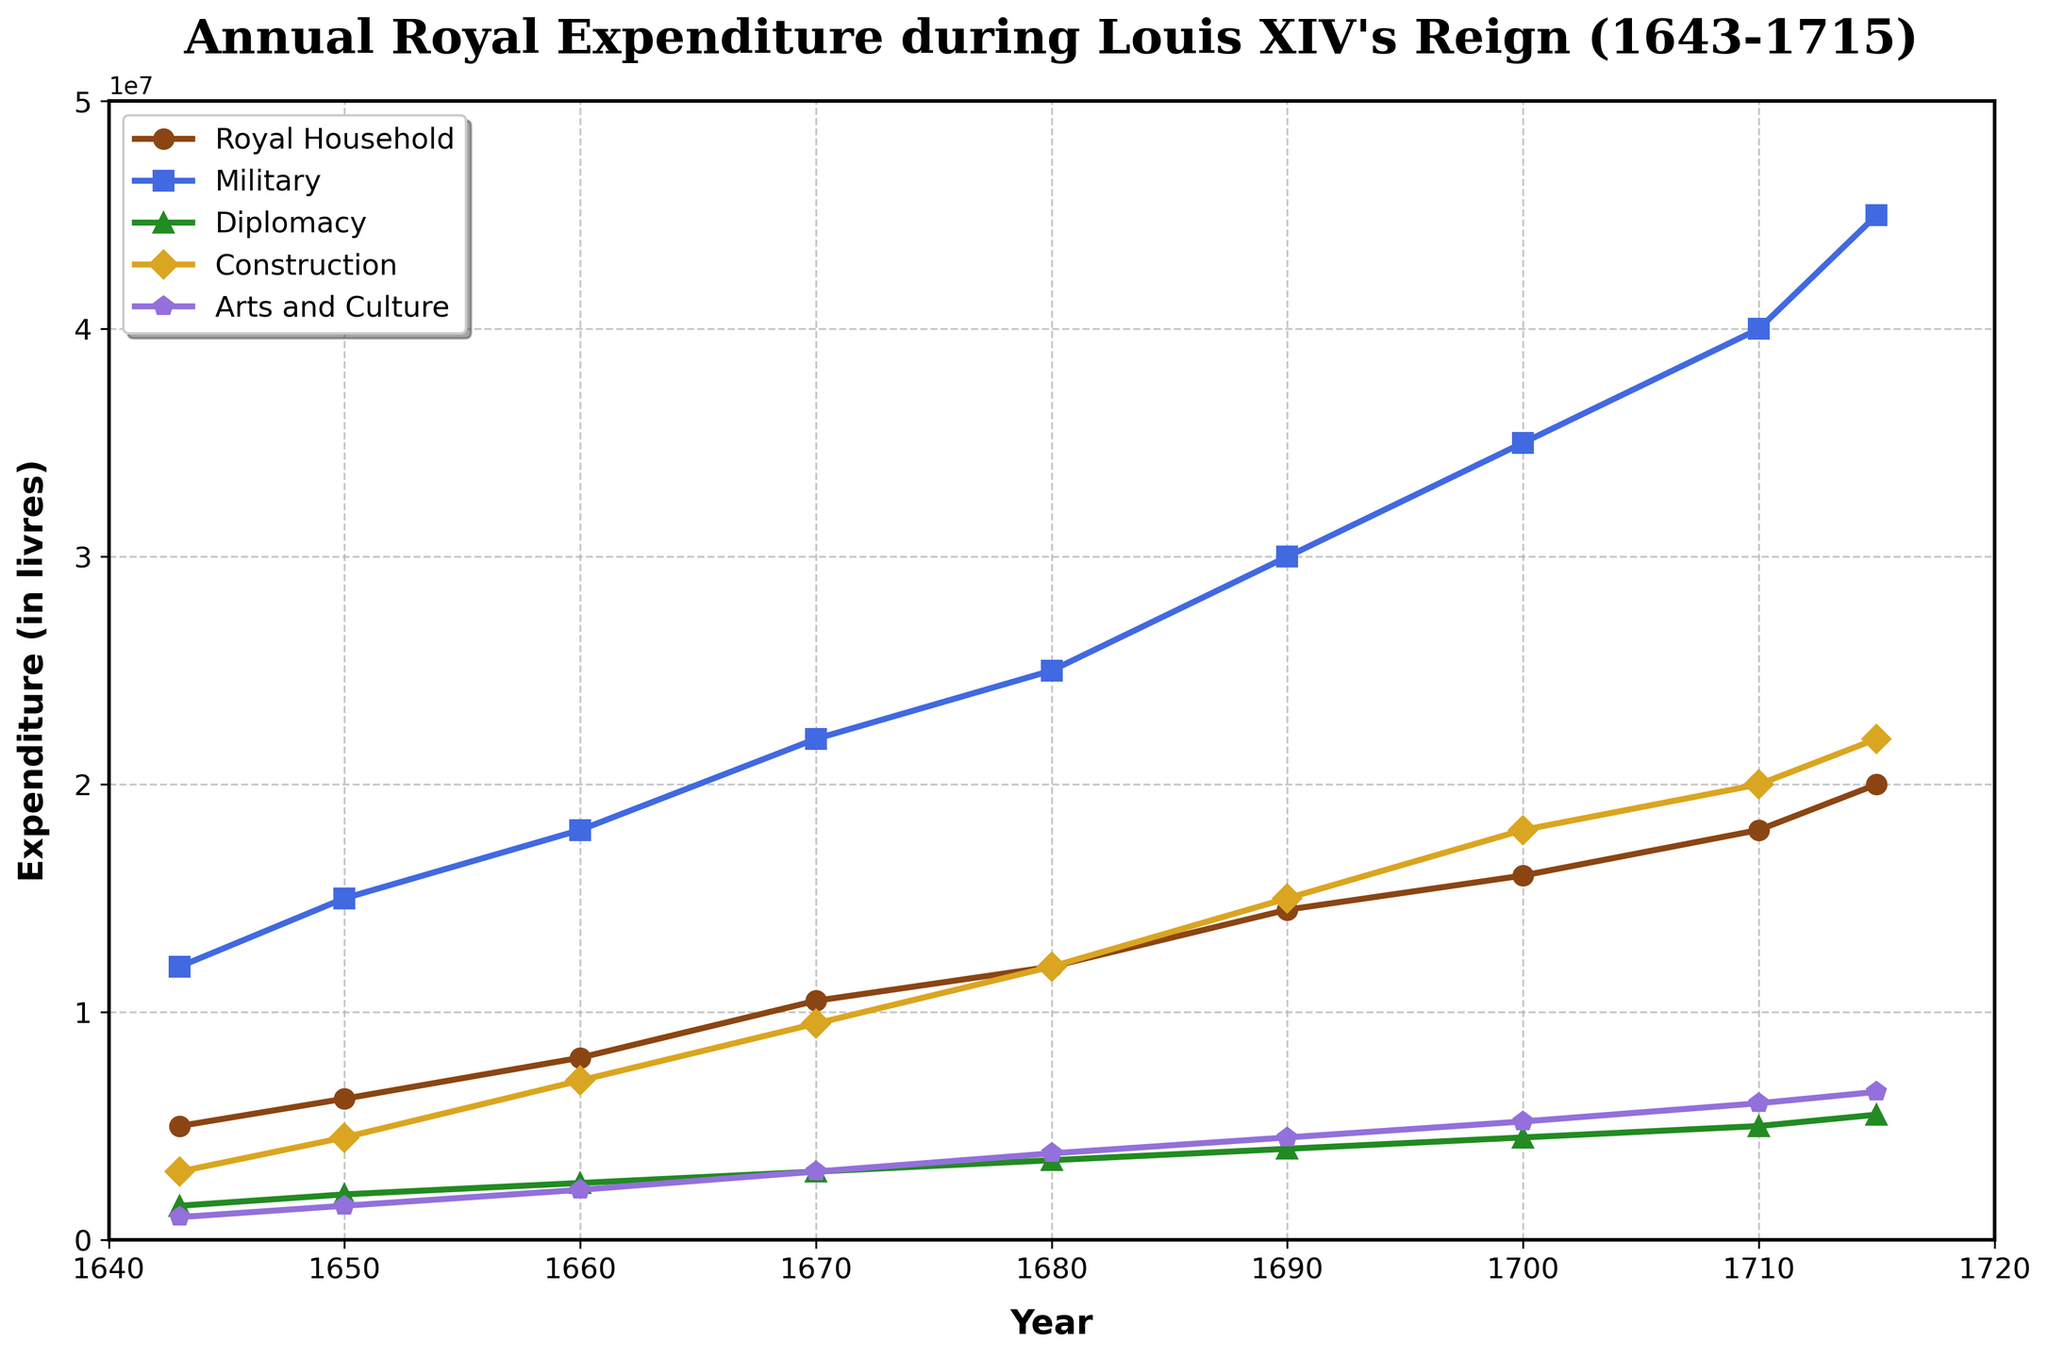What is the highest recorded expenditure on Military? The data shows the Military expenditure increasing over time. The highest Military expenditure can be observed at the last data point in 1715.
Answer: 45000000 livres In which year did Construction expenditure surpass 15 million livres for the first time? To determine this, examine the Construction expenditure values sequentially. The Construction expenditure exceeds 15 million livres for the first time in 1690.
Answer: 1690 How much more was spent on Arts and Culture in 1710 compared to 1643? To find the difference in expenditure on Arts and Culture between 1710 and 1643, subtract the value in 1643 from the value in 1710: 6000000 - 1000000 = 5000000 livres.
Answer: 5000000 livres What is the overall trend in the expenditure on Royal Household from 1643 to 1715? The line for the Royal Household expenditure shows a consistently upward trend from 1643 to 1715. Each year it increases steadily.
Answer: Increasing Compare the expenditure on Diplomacy and Construction in 1700. Which is higher and by how much? In 1700, Diplomacy expenditure is 4500000 livres and Construction expenditure is 18000000 livres. The Construction expenditure exceeds the Diplomacy expenditure by 18000000 - 4500000 = 13500000 livres.
Answer: Construction by 13500000 livres What is the approximate difference in Military spending between 1670 and 1680? Subtract the Military expenditure in 1670 from that in 1680: 25000000 - 22000000 = 3000000 livres.
Answer: 3000000 livres What were the expenditures on the Royal Household and Arts and Culture in 1650? Combine these values. In 1650, the expenditure on the Royal Household was 6200000 livres and on Arts and Culture was 1500000 livres. Sum these values to get: 6200000 + 1500000 = 7700000 livres.
Answer: 7700000 livres Which category had the steepest increase in expenditure over the entire period? By visually assessing the slopes of the lines, the Military expenditure shows the steepest increase from 12000000 in 1643 to 45000000 in 1715.
Answer: Military What year saw the lowest combined expenditure on Military and Diplomacy? Calculate the combined Military and Diplomacy expenditure for each year and find the year with the smallest total. The lowest combined expenditure occurs in 1643 with 12000000 (Military) + 1500000 (Diplomacy) = 13500000 livres.
Answer: 1643 How does the trend in Construction expenditure compare to that of Arts and Culture during Louis XIV's reign? Both expenditures show an upward trend. However, Construction expenditure increases more sharply than Arts and Culture over the years, starting to take off noticeably around 1670, while Arts and Culture expenditure grows more steadily.
Answer: Construction rises more sharply than Arts and Culture 